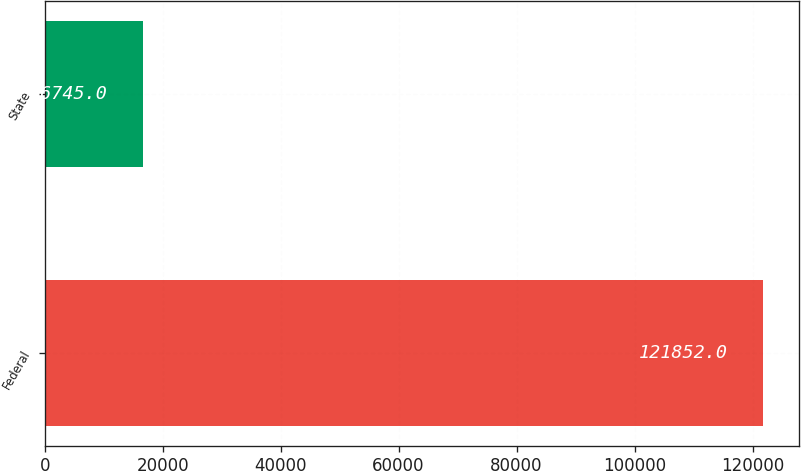Convert chart to OTSL. <chart><loc_0><loc_0><loc_500><loc_500><bar_chart><fcel>Federal<fcel>State<nl><fcel>121852<fcel>16745<nl></chart> 